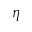Convert formula to latex. <formula><loc_0><loc_0><loc_500><loc_500>\eta</formula> 